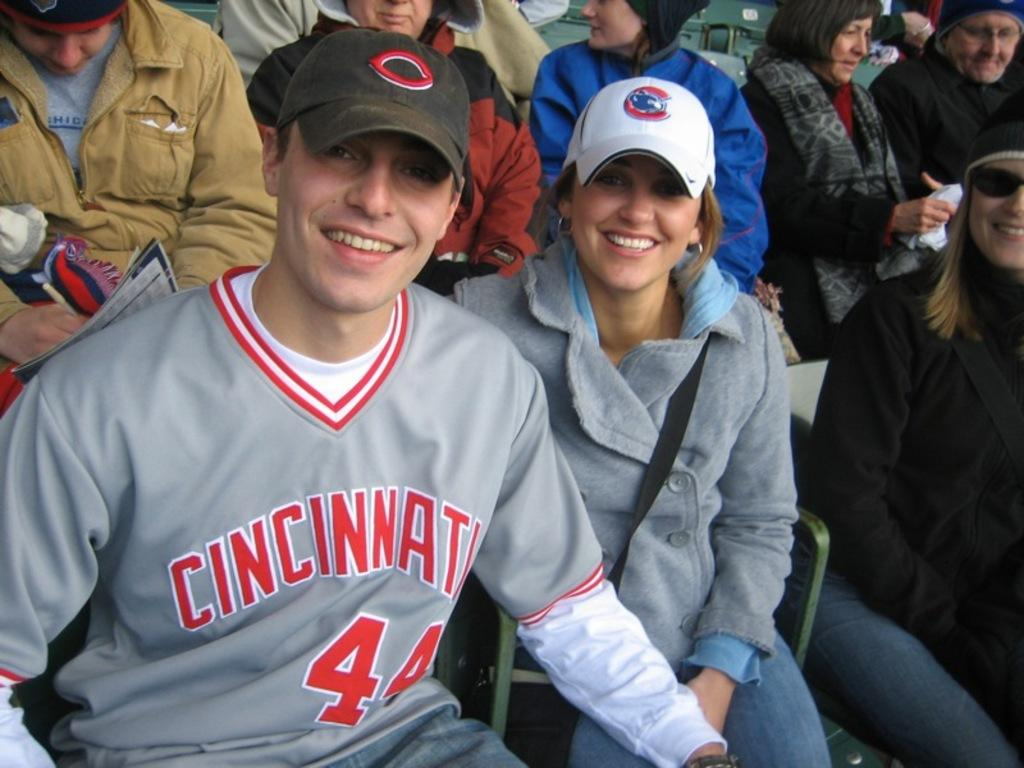<image>
Provide a brief description of the given image. man wearing #44 Cincinnati jersey next to woman with chicago bears cap 